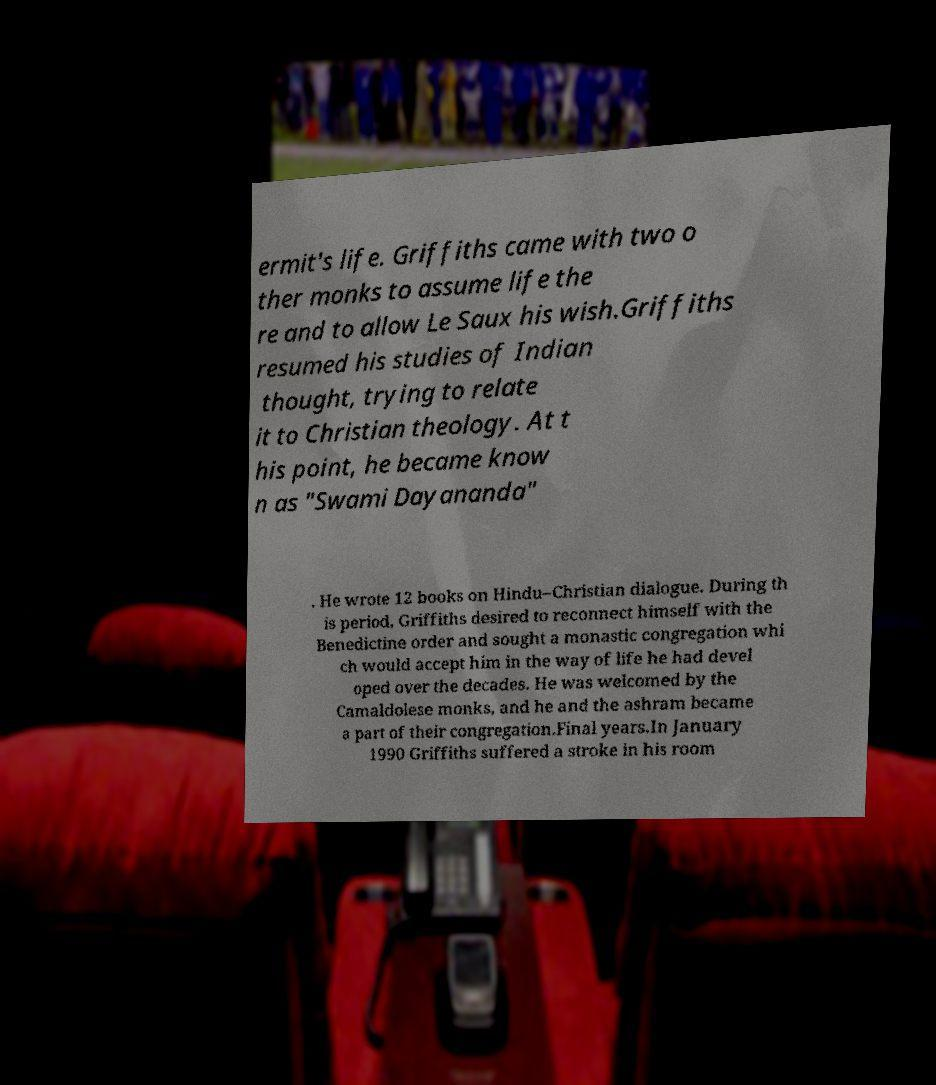What messages or text are displayed in this image? I need them in a readable, typed format. ermit's life. Griffiths came with two o ther monks to assume life the re and to allow Le Saux his wish.Griffiths resumed his studies of Indian thought, trying to relate it to Christian theology. At t his point, he became know n as "Swami Dayananda" . He wrote 12 books on Hindu–Christian dialogue. During th is period, Griffiths desired to reconnect himself with the Benedictine order and sought a monastic congregation whi ch would accept him in the way of life he had devel oped over the decades. He was welcomed by the Camaldolese monks, and he and the ashram became a part of their congregation.Final years.In January 1990 Griffiths suffered a stroke in his room 